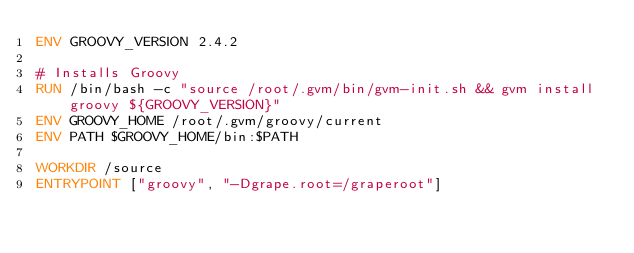<code> <loc_0><loc_0><loc_500><loc_500><_Dockerfile_>ENV GROOVY_VERSION 2.4.2

# Installs Groovy 
RUN /bin/bash -c "source /root/.gvm/bin/gvm-init.sh && gvm install groovy ${GROOVY_VERSION}"
ENV GROOVY_HOME /root/.gvm/groovy/current
ENV PATH $GROOVY_HOME/bin:$PATH

WORKDIR /source
ENTRYPOINT ["groovy", "-Dgrape.root=/graperoot"]</code> 